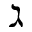<formula> <loc_0><loc_0><loc_500><loc_500>\gimel</formula> 